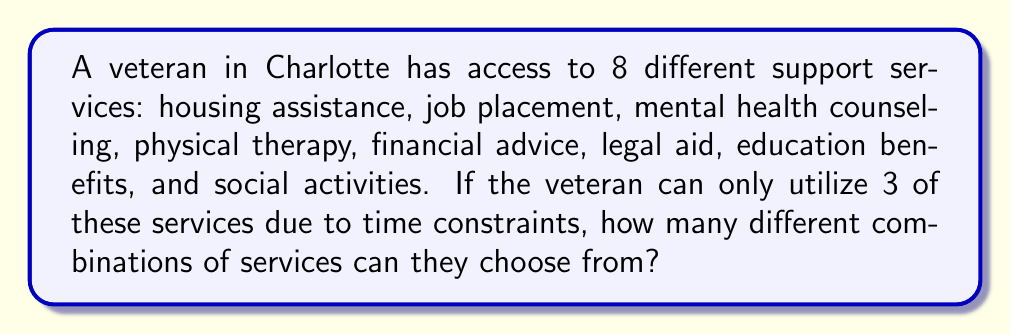Solve this math problem. To solve this problem, we need to use the combination formula. We are selecting 3 services from a total of 8 available services, where the order of selection doesn't matter.

The formula for combinations is:

$$ C(n,r) = \binom{n}{r} = \frac{n!}{r!(n-r)!} $$

Where:
$n$ is the total number of items to choose from (in this case, 8 services)
$r$ is the number of items being chosen (in this case, 3 services)

Let's substitute our values:

$$ C(8,3) = \binom{8}{3} = \frac{8!}{3!(8-3)!} = \frac{8!}{3!5!} $$

Now, let's calculate this step-by-step:

1) $8! = 8 \times 7 \times 6 \times 5!$
2) $3! = 3 \times 2 \times 1 = 6$

Substituting these into our equation:

$$ \frac{8!}{3!5!} = \frac{8 \times 7 \times 6 \times 5!}{6 \times 5!} $$

The $5!$ cancels out in the numerator and denominator:

$$ = \frac{8 \times 7 \times 6}{6} = 8 \times 7 = 56 $$

Therefore, the veteran can choose from 56 different combinations of 3 services out of the 8 available.
Answer: 56 combinations 